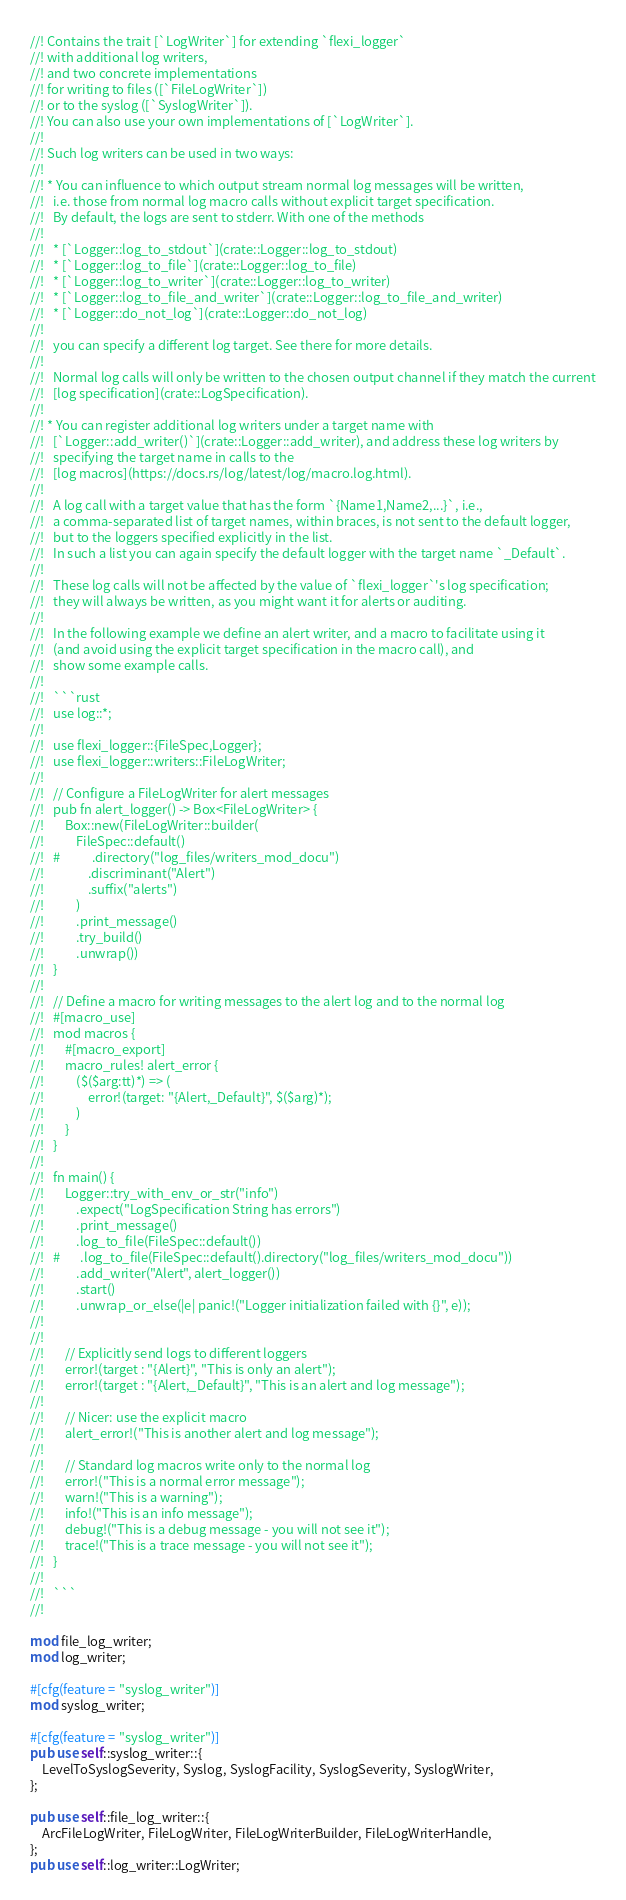<code> <loc_0><loc_0><loc_500><loc_500><_Rust_>//! Contains the trait [`LogWriter`] for extending `flexi_logger`
//! with additional log writers,
//! and two concrete implementations
//! for writing to files ([`FileLogWriter`])
//! or to the syslog ([`SyslogWriter`]).
//! You can also use your own implementations of [`LogWriter`].
//!
//! Such log writers can be used in two ways:
//!
//! * You can influence to which output stream normal log messages will be written,
//!   i.e. those from normal log macro calls without explicit target specification.
//!   By default, the logs are sent to stderr. With one of the methods
//!
//!   * [`Logger::log_to_stdout`](crate::Logger::log_to_stdout)
//!   * [`Logger::log_to_file`](crate::Logger::log_to_file)
//!   * [`Logger::log_to_writer`](crate::Logger::log_to_writer)
//!   * [`Logger::log_to_file_and_writer`](crate::Logger::log_to_file_and_writer)
//!   * [`Logger::do_not_log`](crate::Logger::do_not_log)
//!
//!   you can specify a different log target. See there for more details.
//!
//!   Normal log calls will only be written to the chosen output channel if they match the current
//!   [log specification](crate::LogSpecification).
//!
//! * You can register additional log writers under a target name with
//!   [`Logger::add_writer()`](crate::Logger::add_writer), and address these log writers by
//!   specifying the target name in calls to the
//!   [log macros](https://docs.rs/log/latest/log/macro.log.html).
//!
//!   A log call with a target value that has the form `{Name1,Name2,...}`, i.e.,
//!   a comma-separated list of target names, within braces, is not sent to the default logger,
//!   but to the loggers specified explicitly in the list.
//!   In such a list you can again specify the default logger with the target name `_Default`.
//!
//!   These log calls will not be affected by the value of `flexi_logger`'s log specification;
//!   they will always be written, as you might want it for alerts or auditing.
//!
//!   In the following example we define an alert writer, and a macro to facilitate using it
//!   (and avoid using the explicit target specification in the macro call), and
//!   show some example calls.
//!
//!   ```rust
//!   use log::*;
//!
//!   use flexi_logger::{FileSpec,Logger};
//!   use flexi_logger::writers::FileLogWriter;
//!
//!   // Configure a FileLogWriter for alert messages
//!   pub fn alert_logger() -> Box<FileLogWriter> {
//!       Box::new(FileLogWriter::builder(
//!           FileSpec::default()
//!   #           .directory("log_files/writers_mod_docu")
//!               .discriminant("Alert")
//!               .suffix("alerts")
//!           )
//!           .print_message()
//!           .try_build()
//!           .unwrap())
//!   }
//!
//!   // Define a macro for writing messages to the alert log and to the normal log
//!   #[macro_use]
//!   mod macros {
//!       #[macro_export]
//!       macro_rules! alert_error {
//!           ($($arg:tt)*) => (
//!               error!(target: "{Alert,_Default}", $($arg)*);
//!           )
//!       }
//!   }
//!
//!   fn main() {
//!       Logger::try_with_env_or_str("info")
//!           .expect("LogSpecification String has errors")
//!           .print_message()
//!           .log_to_file(FileSpec::default())
//!   #       .log_to_file(FileSpec::default().directory("log_files/writers_mod_docu"))
//!           .add_writer("Alert", alert_logger())
//!           .start()
//!           .unwrap_or_else(|e| panic!("Logger initialization failed with {}", e));
//!
//!
//!       // Explicitly send logs to different loggers
//!       error!(target : "{Alert}", "This is only an alert");
//!       error!(target : "{Alert,_Default}", "This is an alert and log message");
//!
//!       // Nicer: use the explicit macro
//!       alert_error!("This is another alert and log message");
//!
//!       // Standard log macros write only to the normal log
//!       error!("This is a normal error message");
//!       warn!("This is a warning");
//!       info!("This is an info message");
//!       debug!("This is a debug message - you will not see it");
//!       trace!("This is a trace message - you will not see it");
//!   }
//!
//!   ```
//!

mod file_log_writer;
mod log_writer;

#[cfg(feature = "syslog_writer")]
mod syslog_writer;

#[cfg(feature = "syslog_writer")]
pub use self::syslog_writer::{
    LevelToSyslogSeverity, Syslog, SyslogFacility, SyslogSeverity, SyslogWriter,
};

pub use self::file_log_writer::{
    ArcFileLogWriter, FileLogWriter, FileLogWriterBuilder, FileLogWriterHandle,
};
pub use self::log_writer::LogWriter;
</code> 